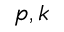Convert formula to latex. <formula><loc_0><loc_0><loc_500><loc_500>p , k</formula> 